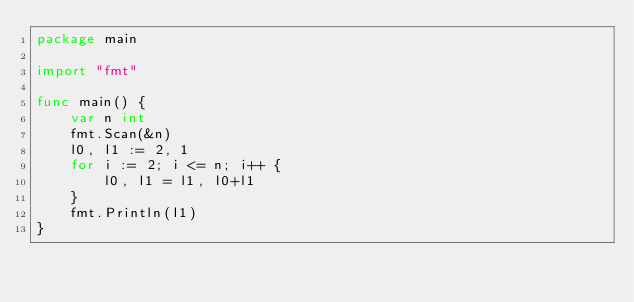<code> <loc_0><loc_0><loc_500><loc_500><_Go_>package main

import "fmt"

func main() {
	var n int
	fmt.Scan(&n)
	l0, l1 := 2, 1
	for i := 2; i <= n; i++ {
		l0, l1 = l1, l0+l1
	}
	fmt.Println(l1)
}</code> 